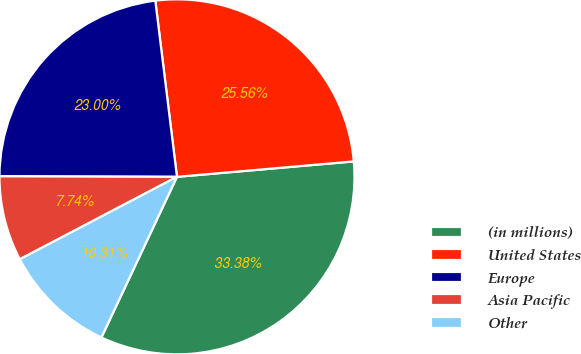Convert chart to OTSL. <chart><loc_0><loc_0><loc_500><loc_500><pie_chart><fcel>(in millions)<fcel>United States<fcel>Europe<fcel>Asia Pacific<fcel>Other<nl><fcel>33.38%<fcel>25.56%<fcel>23.0%<fcel>7.74%<fcel>10.31%<nl></chart> 